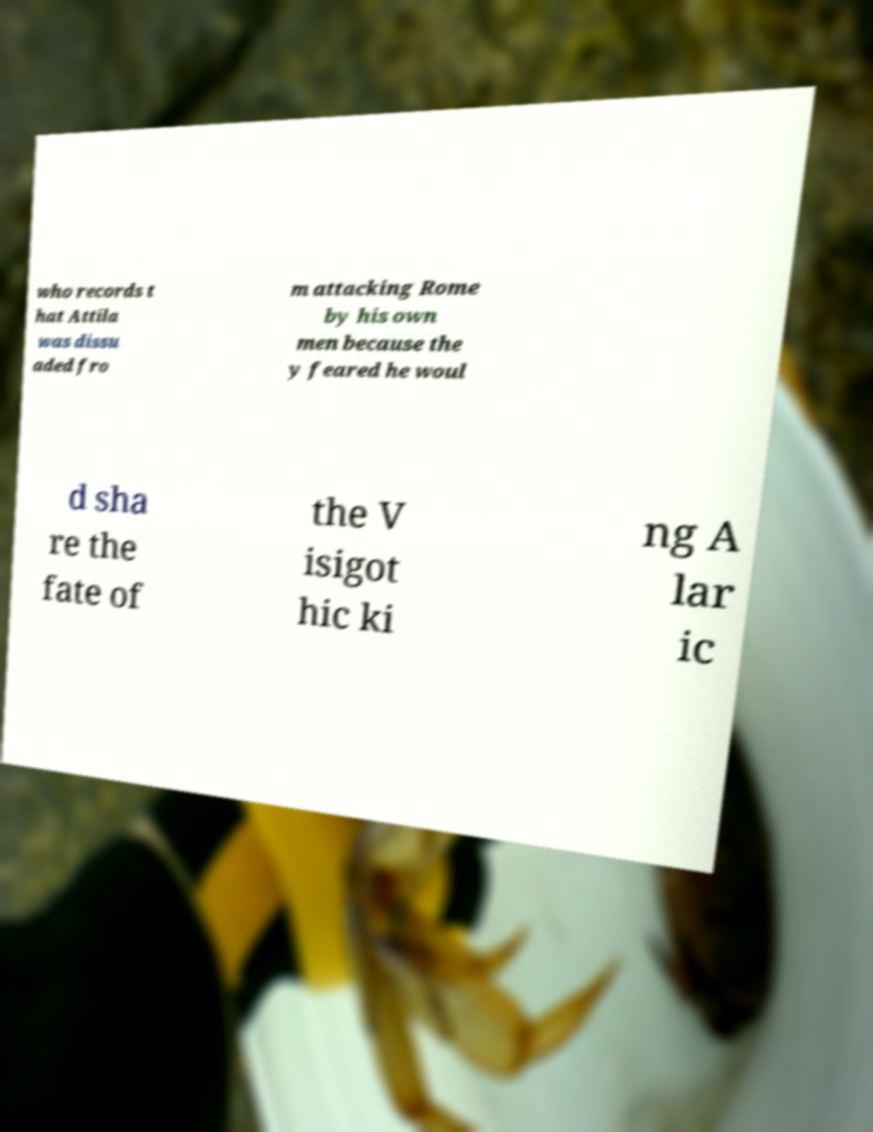Can you read and provide the text displayed in the image?This photo seems to have some interesting text. Can you extract and type it out for me? who records t hat Attila was dissu aded fro m attacking Rome by his own men because the y feared he woul d sha re the fate of the V isigot hic ki ng A lar ic 